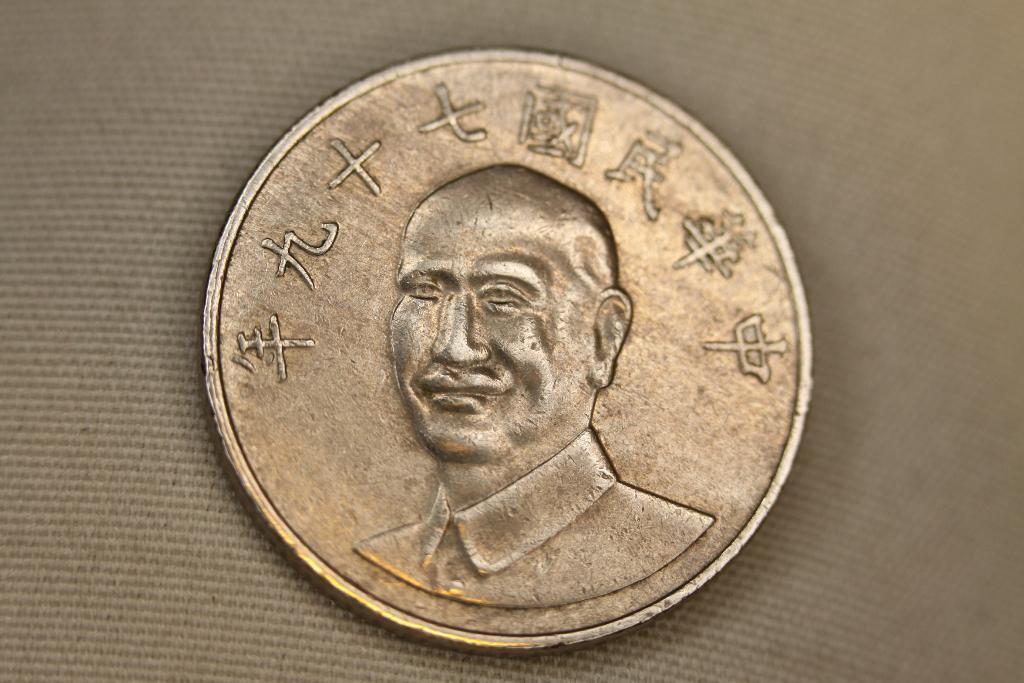What is the main object in the image? There is a coin in the image. What is the coin placed on? The coin is on a cloth. What can be seen on the surface of the coin? There is an image of a person on the coin. Are there any words or symbols on the coin? Yes, there is text on the coin. What type of fruit is being divided in the battle depicted on the coin? There is no battle or fruit depicted on the coin; it features an image of a person and text. 